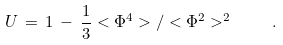Convert formula to latex. <formula><loc_0><loc_0><loc_500><loc_500>U \, = \, 1 \, - \, \frac { 1 } { 3 } < \Phi ^ { 4 } > / < \Phi ^ { 2 } > ^ { 2 } \quad .</formula> 